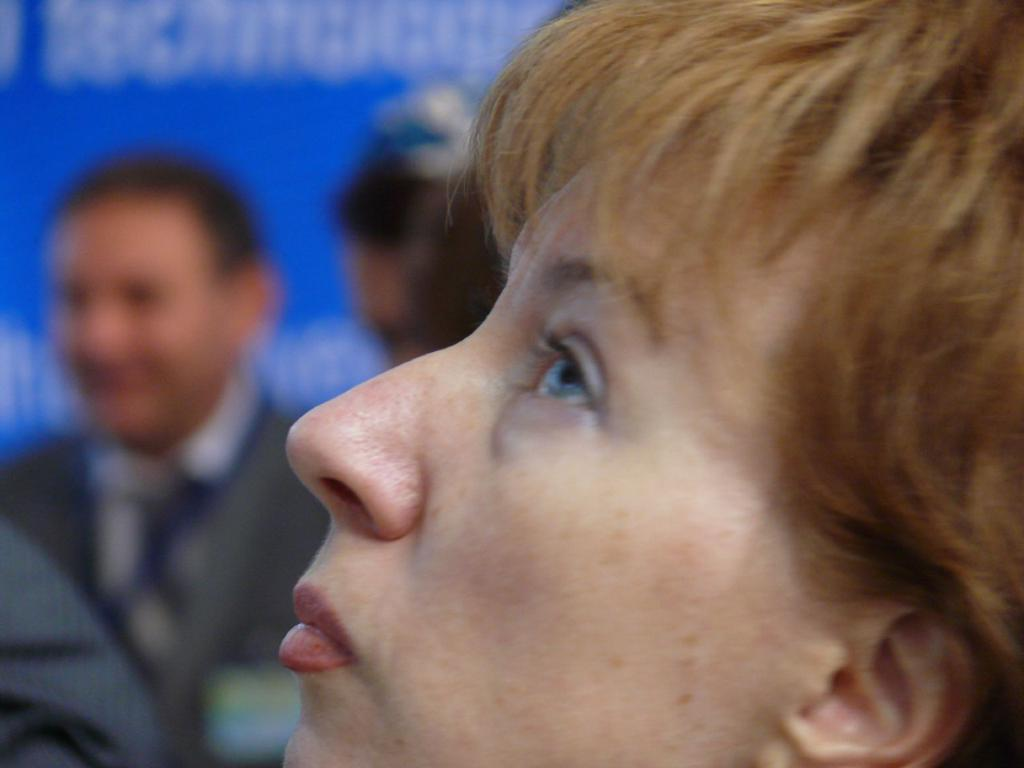What is the main subject of the image? The main subject of the image is a zoomed-in picture of a woman's face. Can you describe the background of the image? There are people visible in the background of the image, and there is a banner with text. What type of game is the woman playing in the image? There is no game visible in the image; it is a zoomed-in picture of a woman's face. How many sisters does the woman in the image have? There is no information about the woman's family in the image, so we cannot determine the number of sisters she has. 